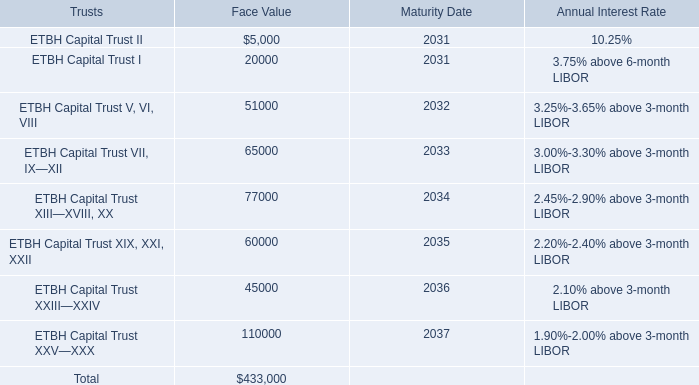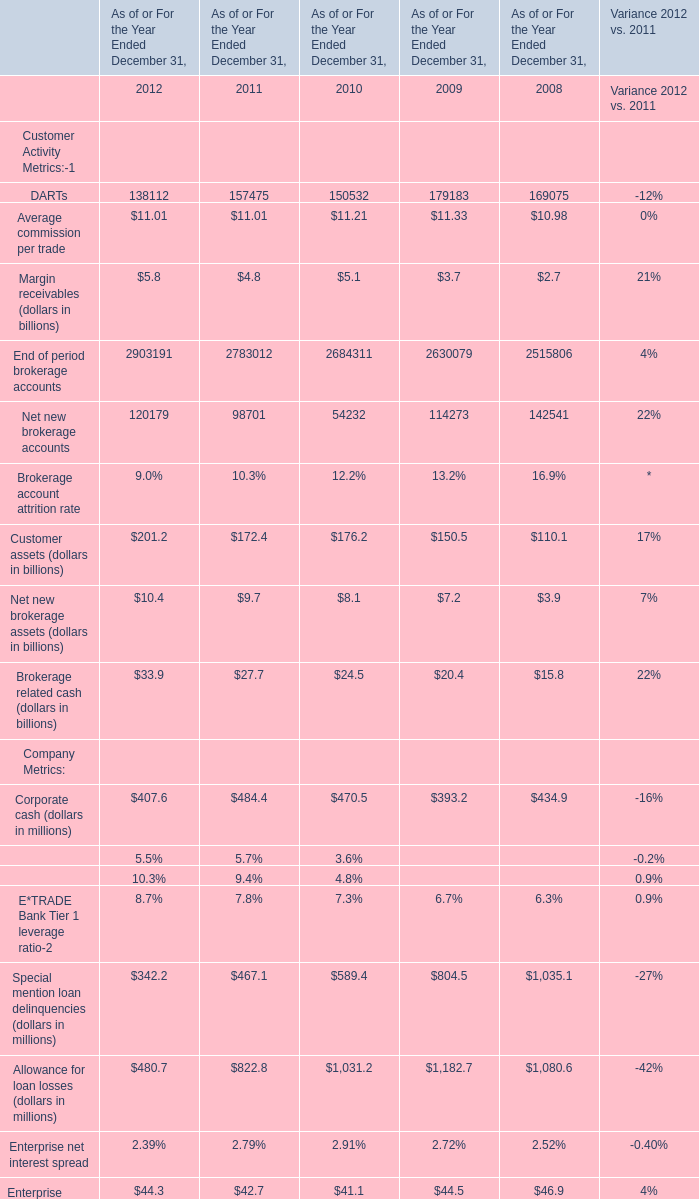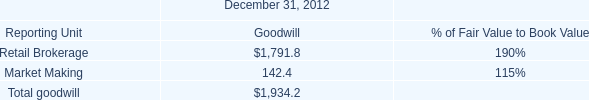What is the sum of Average commission per trade and Margin receivables in 2012? (in billion) 
Computations: (11.01 + 5.8)
Answer: 16.81. 